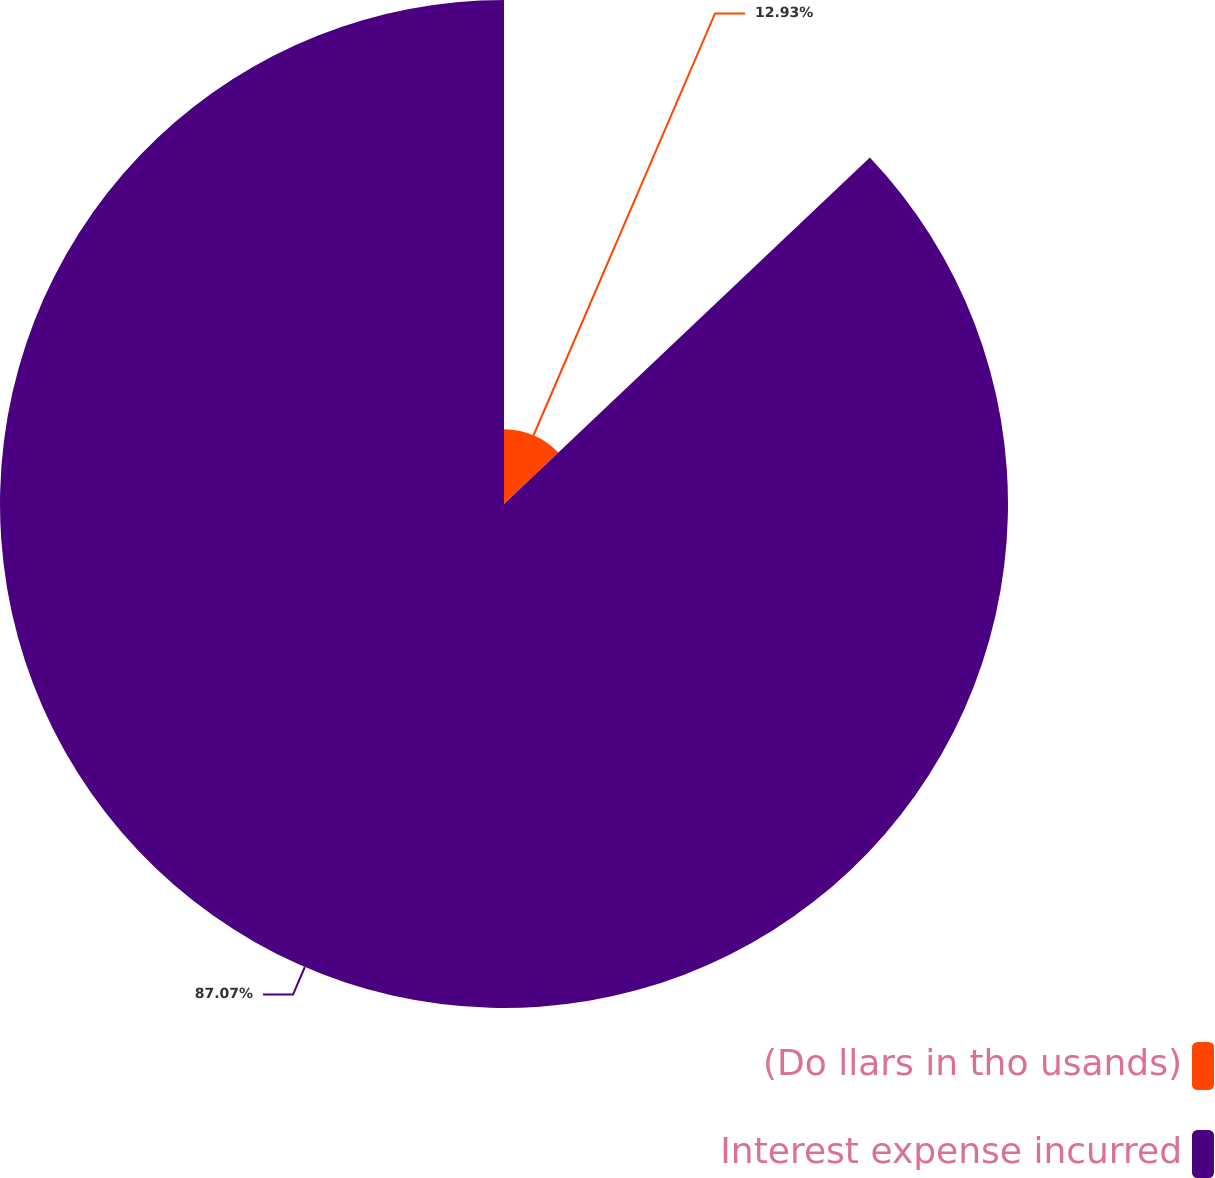Convert chart to OTSL. <chart><loc_0><loc_0><loc_500><loc_500><pie_chart><fcel>(Do llars in tho usands)<fcel>Interest expense incurred<nl><fcel>12.93%<fcel>87.07%<nl></chart> 